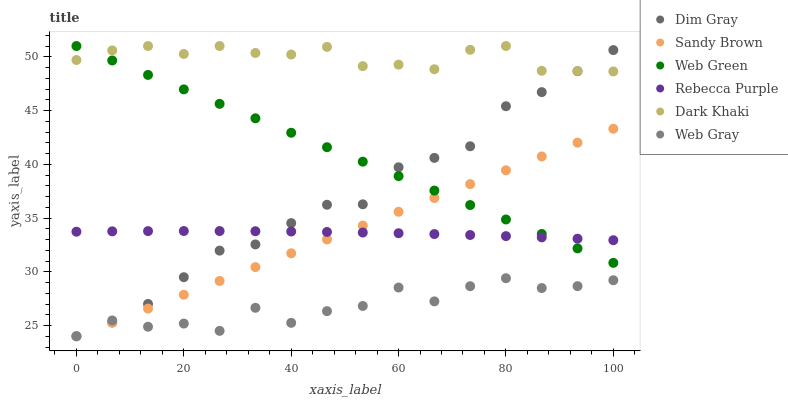Does Web Gray have the minimum area under the curve?
Answer yes or no. Yes. Does Dark Khaki have the maximum area under the curve?
Answer yes or no. Yes. Does Web Green have the minimum area under the curve?
Answer yes or no. No. Does Web Green have the maximum area under the curve?
Answer yes or no. No. Is Sandy Brown the smoothest?
Answer yes or no. Yes. Is Web Gray the roughest?
Answer yes or no. Yes. Is Web Green the smoothest?
Answer yes or no. No. Is Web Green the roughest?
Answer yes or no. No. Does Dim Gray have the lowest value?
Answer yes or no. Yes. Does Web Green have the lowest value?
Answer yes or no. No. Does Dark Khaki have the highest value?
Answer yes or no. Yes. Does Web Gray have the highest value?
Answer yes or no. No. Is Web Gray less than Web Green?
Answer yes or no. Yes. Is Dark Khaki greater than Web Gray?
Answer yes or no. Yes. Does Web Gray intersect Sandy Brown?
Answer yes or no. Yes. Is Web Gray less than Sandy Brown?
Answer yes or no. No. Is Web Gray greater than Sandy Brown?
Answer yes or no. No. Does Web Gray intersect Web Green?
Answer yes or no. No. 